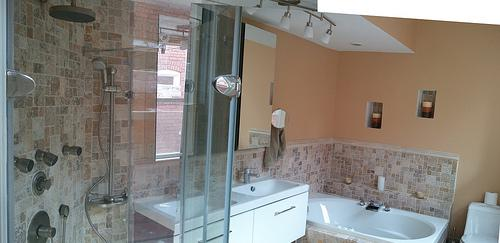Question: where is this scene?
Choices:
A. A kitchen.
B. A bathroom.
C. A den.
D. A basement.
Answer with the letter. Answer: B Question: what is in the wall cut-outs?
Choices:
A. Pictures.
B. Paintings.
C. Trinkets.
D. Candles.
Answer with the letter. Answer: D Question: how many sinks are there?
Choices:
A. Two.
B. Three.
C. One.
D. Four.
Answer with the letter. Answer: A Question: when is this?
Choices:
A. During the day.
B. At night.
C. Noon.
D. Sunset.
Answer with the letter. Answer: A Question: what are the shower doors made of?
Choices:
A. Cloth.
B. Glass.
C. Wood.
D. Plastic.
Answer with the letter. Answer: B 